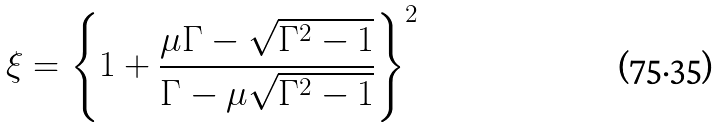<formula> <loc_0><loc_0><loc_500><loc_500>\xi = \left \{ 1 + \frac { \mu \Gamma - \sqrt { \Gamma ^ { 2 } - 1 } } { \Gamma - \mu \sqrt { \Gamma ^ { 2 } - 1 } } \right \} ^ { 2 }</formula> 